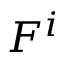Convert formula to latex. <formula><loc_0><loc_0><loc_500><loc_500>F ^ { i }</formula> 